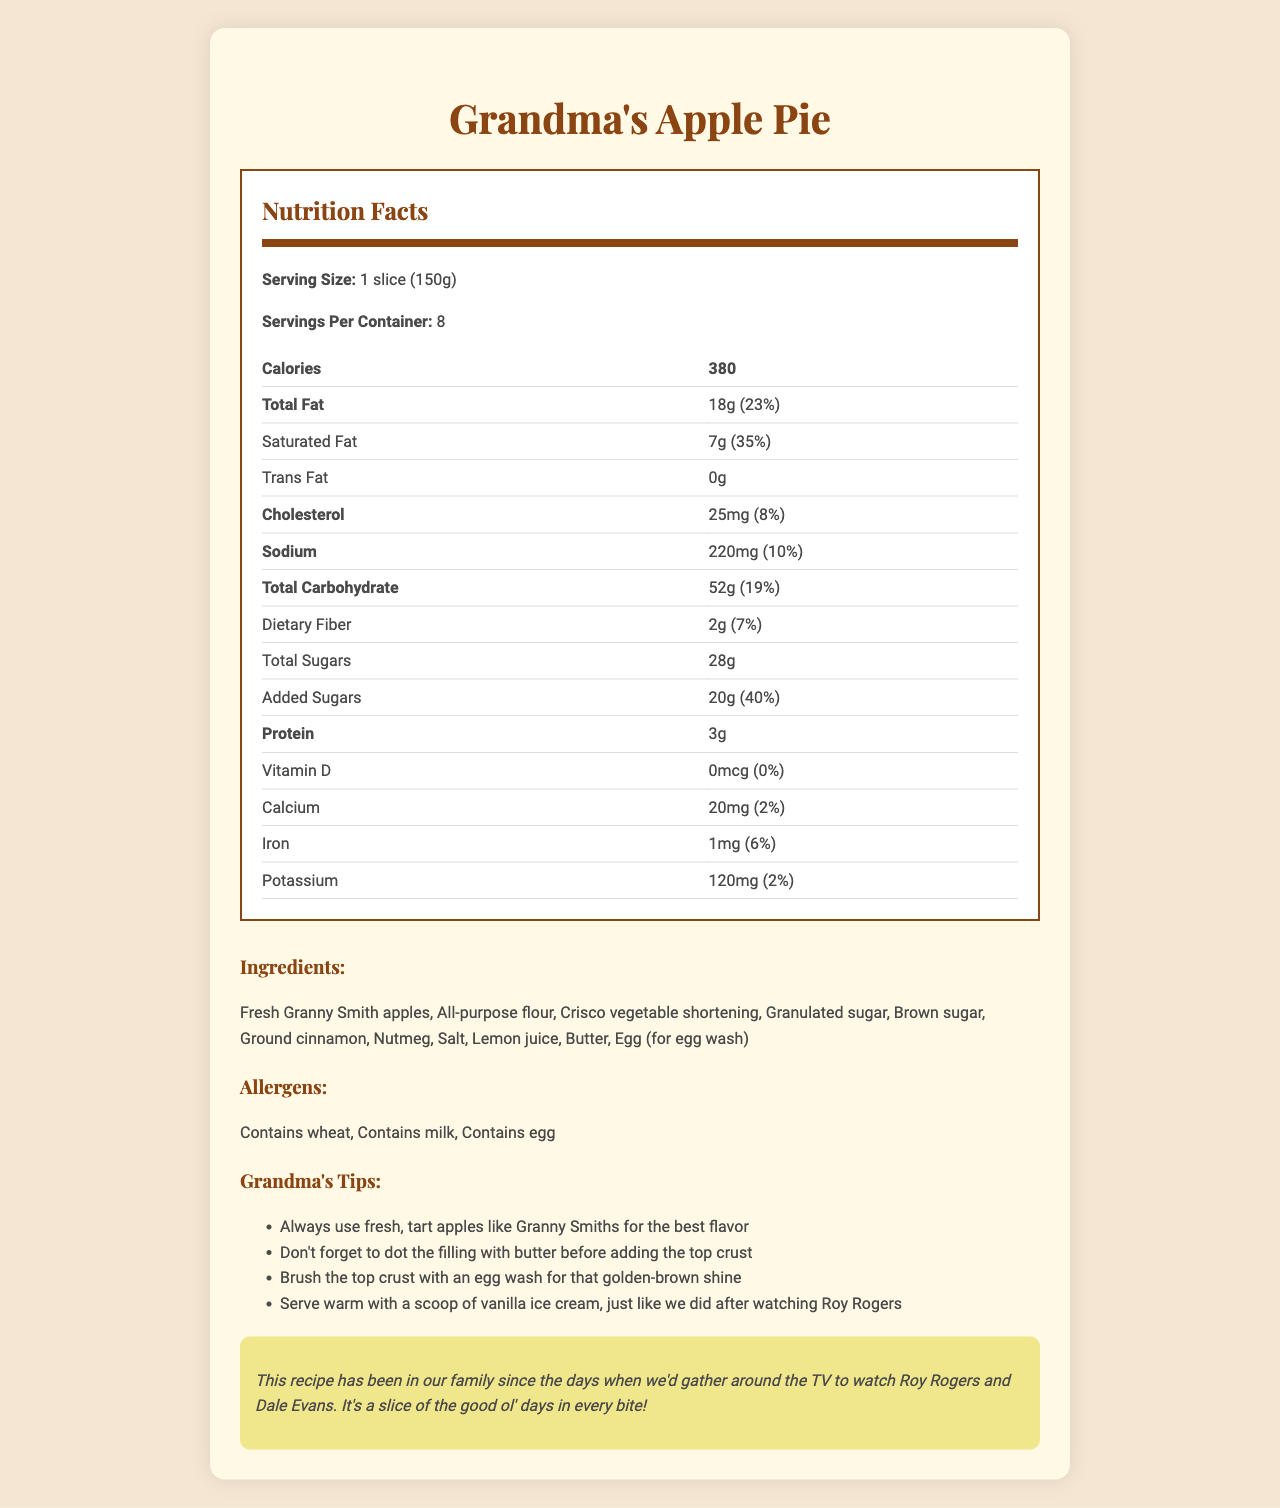what is the serving size for the apple pie? The serving size is stated explicitly at the top of the Nutrition Facts section.
Answer: 1 slice (150g) how many calories does one slice of apple pie contain? The calorie count for one slice is listed directly below the serving size in the Nutrition Facts section.
Answer: 380 what is the percentage of the daily value for saturated fat in one slice of apple pie? The percentage daily value for saturated fat is listed next to the amount of saturated fat in grams.
Answer: 35% how much sodium is in a serving of apple pie? The sodium content is listed in milligrams in the Nutrition Facts.
Answer: 220 mg how much protein is in one slice of apple pie? The protein content for one serving is listed in grams.
Answer: 3g how much iron does one serving of apple pie provide? The iron content is listed in the Nutrition Facts and shows 1 mg per serving with a 6% daily value.
Answer: 1 mg which ingredient is not part of the apple pie? A. Fresh apples B. Crisco vegetable shortening C. Corn syrup D. Ground cinnamon The ingredients list includes Fresh Granny Smith apples, Crisco vegetable shortening, and Ground cinnamon, but not Corn syrup.
Answer: C which allergen is not present in the apple pie? A. Wheat B. Milk C. Egg D. Soy The document lists wheat, milk, and egg as allergens but does not mention soy.
Answer: D is there any vitamin D in the apple pie? The section for vitamin D states 0 mcg and 0% daily value.
Answer: No does the pie contain any added sugars? The Nutrition Facts section lists 20g of added sugars with a daily value of 40%.
Answer: Yes summarize the main details of the document. The document gives a comprehensive overview of the nutritional content, ingredients, allergen information, and includes personal tips and a nostalgic note.
Answer: The document provides a detailed Nutrition Facts label for Grandma's Apple Pie, including calorie count, fat content, sodium, and carbohydrate values. It lists ingredients, allergens, and grandma's baking tips, along with a nostalgic note about the family recipe's history. what is the source of the nostalgic note? The document does not provide information about the exact source of the nostalgic note; it simply includes the text.
Answer: Cannot be determined 